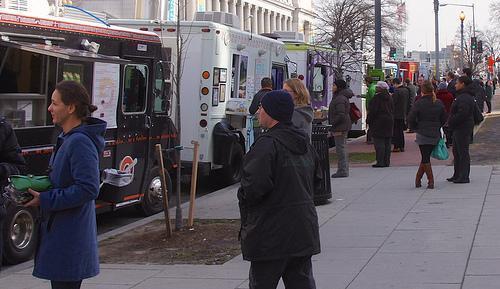How many light poles are there?
Give a very brief answer. 2. 